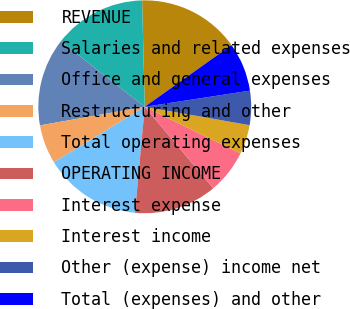Convert chart to OTSL. <chart><loc_0><loc_0><loc_500><loc_500><pie_chart><fcel>REVENUE<fcel>Salaries and related expenses<fcel>Office and general expenses<fcel>Restructuring and other<fcel>Total operating expenses<fcel>OPERATING INCOME<fcel>Interest expense<fcel>Interest income<fcel>Other (expense) income net<fcel>Total (expenses) and other<nl><fcel>15.56%<fcel>14.07%<fcel>13.33%<fcel>5.93%<fcel>14.81%<fcel>12.59%<fcel>6.67%<fcel>4.44%<fcel>5.19%<fcel>7.41%<nl></chart> 